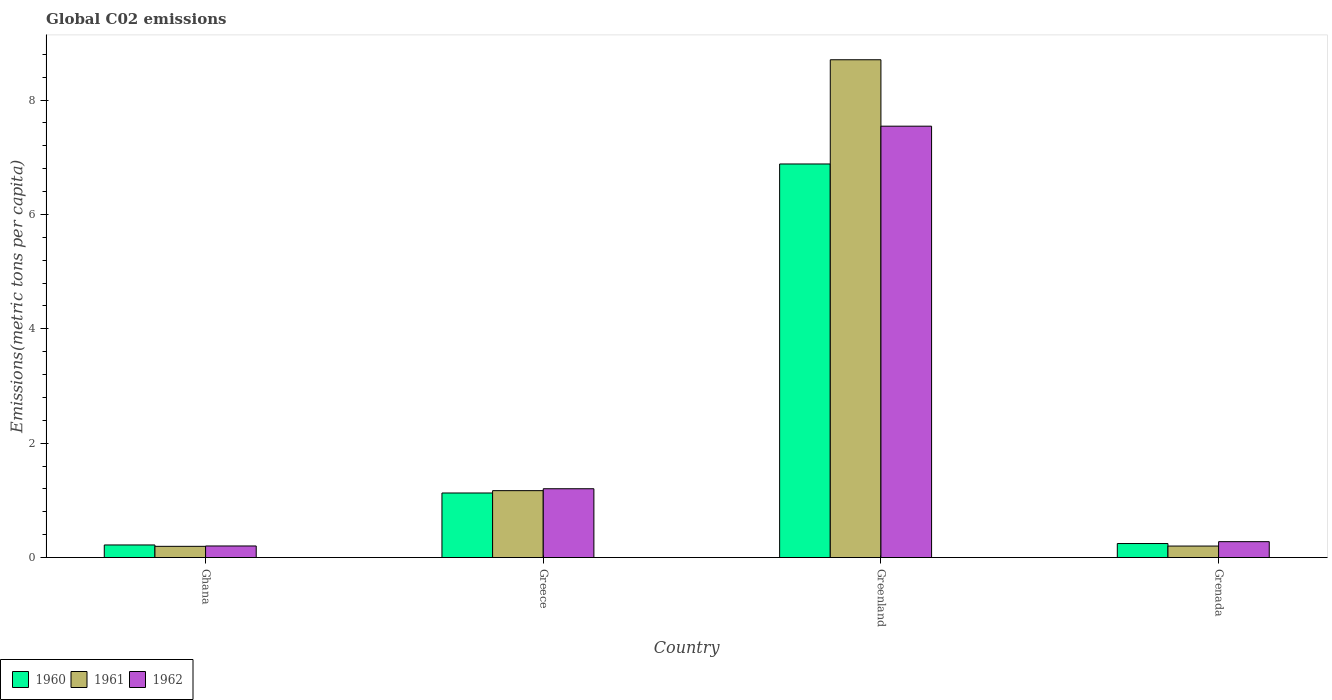How many different coloured bars are there?
Ensure brevity in your answer.  3. How many groups of bars are there?
Provide a short and direct response. 4. Are the number of bars on each tick of the X-axis equal?
Provide a succinct answer. Yes. How many bars are there on the 4th tick from the left?
Offer a terse response. 3. How many bars are there on the 4th tick from the right?
Provide a succinct answer. 3. In how many cases, is the number of bars for a given country not equal to the number of legend labels?
Give a very brief answer. 0. What is the amount of CO2 emitted in in 1960 in Grenada?
Offer a terse response. 0.24. Across all countries, what is the maximum amount of CO2 emitted in in 1960?
Offer a terse response. 6.88. Across all countries, what is the minimum amount of CO2 emitted in in 1960?
Your answer should be very brief. 0.22. In which country was the amount of CO2 emitted in in 1962 maximum?
Your answer should be compact. Greenland. In which country was the amount of CO2 emitted in in 1960 minimum?
Your answer should be very brief. Ghana. What is the total amount of CO2 emitted in in 1962 in the graph?
Make the answer very short. 9.23. What is the difference between the amount of CO2 emitted in in 1960 in Greece and that in Grenada?
Ensure brevity in your answer.  0.88. What is the difference between the amount of CO2 emitted in in 1960 in Greece and the amount of CO2 emitted in in 1962 in Greenland?
Your answer should be very brief. -6.41. What is the average amount of CO2 emitted in in 1960 per country?
Ensure brevity in your answer.  2.12. What is the difference between the amount of CO2 emitted in of/in 1961 and amount of CO2 emitted in of/in 1962 in Greenland?
Ensure brevity in your answer.  1.16. In how many countries, is the amount of CO2 emitted in in 1960 greater than 0.8 metric tons per capita?
Offer a very short reply. 2. What is the ratio of the amount of CO2 emitted in in 1960 in Greece to that in Greenland?
Your answer should be compact. 0.16. Is the amount of CO2 emitted in in 1961 in Greenland less than that in Grenada?
Give a very brief answer. No. Is the difference between the amount of CO2 emitted in in 1961 in Ghana and Grenada greater than the difference between the amount of CO2 emitted in in 1962 in Ghana and Grenada?
Provide a succinct answer. Yes. What is the difference between the highest and the second highest amount of CO2 emitted in in 1961?
Ensure brevity in your answer.  7.54. What is the difference between the highest and the lowest amount of CO2 emitted in in 1961?
Make the answer very short. 8.51. In how many countries, is the amount of CO2 emitted in in 1960 greater than the average amount of CO2 emitted in in 1960 taken over all countries?
Your answer should be compact. 1. Is the sum of the amount of CO2 emitted in in 1960 in Greenland and Grenada greater than the maximum amount of CO2 emitted in in 1961 across all countries?
Your answer should be compact. No. What does the 3rd bar from the right in Greece represents?
Your answer should be very brief. 1960. Is it the case that in every country, the sum of the amount of CO2 emitted in in 1960 and amount of CO2 emitted in in 1961 is greater than the amount of CO2 emitted in in 1962?
Ensure brevity in your answer.  Yes. Are all the bars in the graph horizontal?
Your response must be concise. No. How many countries are there in the graph?
Make the answer very short. 4. What is the difference between two consecutive major ticks on the Y-axis?
Ensure brevity in your answer.  2. Are the values on the major ticks of Y-axis written in scientific E-notation?
Offer a terse response. No. Does the graph contain grids?
Your answer should be compact. No. Where does the legend appear in the graph?
Provide a succinct answer. Bottom left. How many legend labels are there?
Make the answer very short. 3. What is the title of the graph?
Ensure brevity in your answer.  Global C02 emissions. What is the label or title of the X-axis?
Offer a very short reply. Country. What is the label or title of the Y-axis?
Ensure brevity in your answer.  Emissions(metric tons per capita). What is the Emissions(metric tons per capita) in 1960 in Ghana?
Ensure brevity in your answer.  0.22. What is the Emissions(metric tons per capita) in 1961 in Ghana?
Offer a terse response. 0.2. What is the Emissions(metric tons per capita) of 1962 in Ghana?
Provide a short and direct response. 0.2. What is the Emissions(metric tons per capita) of 1960 in Greece?
Your response must be concise. 1.13. What is the Emissions(metric tons per capita) of 1961 in Greece?
Your response must be concise. 1.17. What is the Emissions(metric tons per capita) in 1962 in Greece?
Ensure brevity in your answer.  1.2. What is the Emissions(metric tons per capita) of 1960 in Greenland?
Offer a terse response. 6.88. What is the Emissions(metric tons per capita) of 1961 in Greenland?
Offer a very short reply. 8.71. What is the Emissions(metric tons per capita) of 1962 in Greenland?
Your answer should be very brief. 7.54. What is the Emissions(metric tons per capita) of 1960 in Grenada?
Provide a short and direct response. 0.24. What is the Emissions(metric tons per capita) in 1961 in Grenada?
Provide a succinct answer. 0.2. What is the Emissions(metric tons per capita) in 1962 in Grenada?
Your answer should be very brief. 0.28. Across all countries, what is the maximum Emissions(metric tons per capita) of 1960?
Keep it short and to the point. 6.88. Across all countries, what is the maximum Emissions(metric tons per capita) of 1961?
Your answer should be compact. 8.71. Across all countries, what is the maximum Emissions(metric tons per capita) in 1962?
Keep it short and to the point. 7.54. Across all countries, what is the minimum Emissions(metric tons per capita) of 1960?
Offer a terse response. 0.22. Across all countries, what is the minimum Emissions(metric tons per capita) of 1961?
Your response must be concise. 0.2. Across all countries, what is the minimum Emissions(metric tons per capita) of 1962?
Keep it short and to the point. 0.2. What is the total Emissions(metric tons per capita) in 1960 in the graph?
Provide a succinct answer. 8.48. What is the total Emissions(metric tons per capita) of 1961 in the graph?
Give a very brief answer. 10.27. What is the total Emissions(metric tons per capita) of 1962 in the graph?
Keep it short and to the point. 9.23. What is the difference between the Emissions(metric tons per capita) in 1960 in Ghana and that in Greece?
Provide a short and direct response. -0.91. What is the difference between the Emissions(metric tons per capita) in 1961 in Ghana and that in Greece?
Provide a short and direct response. -0.97. What is the difference between the Emissions(metric tons per capita) of 1962 in Ghana and that in Greece?
Keep it short and to the point. -1. What is the difference between the Emissions(metric tons per capita) in 1960 in Ghana and that in Greenland?
Your response must be concise. -6.66. What is the difference between the Emissions(metric tons per capita) of 1961 in Ghana and that in Greenland?
Your response must be concise. -8.51. What is the difference between the Emissions(metric tons per capita) in 1962 in Ghana and that in Greenland?
Make the answer very short. -7.34. What is the difference between the Emissions(metric tons per capita) of 1960 in Ghana and that in Grenada?
Keep it short and to the point. -0.02. What is the difference between the Emissions(metric tons per capita) of 1961 in Ghana and that in Grenada?
Make the answer very short. -0. What is the difference between the Emissions(metric tons per capita) of 1962 in Ghana and that in Grenada?
Keep it short and to the point. -0.08. What is the difference between the Emissions(metric tons per capita) in 1960 in Greece and that in Greenland?
Keep it short and to the point. -5.75. What is the difference between the Emissions(metric tons per capita) of 1961 in Greece and that in Greenland?
Make the answer very short. -7.54. What is the difference between the Emissions(metric tons per capita) of 1962 in Greece and that in Greenland?
Your response must be concise. -6.34. What is the difference between the Emissions(metric tons per capita) of 1960 in Greece and that in Grenada?
Give a very brief answer. 0.88. What is the difference between the Emissions(metric tons per capita) of 1961 in Greece and that in Grenada?
Give a very brief answer. 0.97. What is the difference between the Emissions(metric tons per capita) in 1962 in Greece and that in Grenada?
Keep it short and to the point. 0.93. What is the difference between the Emissions(metric tons per capita) in 1960 in Greenland and that in Grenada?
Provide a succinct answer. 6.64. What is the difference between the Emissions(metric tons per capita) in 1961 in Greenland and that in Grenada?
Your answer should be very brief. 8.5. What is the difference between the Emissions(metric tons per capita) in 1962 in Greenland and that in Grenada?
Provide a succinct answer. 7.27. What is the difference between the Emissions(metric tons per capita) in 1960 in Ghana and the Emissions(metric tons per capita) in 1961 in Greece?
Offer a terse response. -0.95. What is the difference between the Emissions(metric tons per capita) of 1960 in Ghana and the Emissions(metric tons per capita) of 1962 in Greece?
Your answer should be compact. -0.98. What is the difference between the Emissions(metric tons per capita) in 1961 in Ghana and the Emissions(metric tons per capita) in 1962 in Greece?
Provide a succinct answer. -1.01. What is the difference between the Emissions(metric tons per capita) of 1960 in Ghana and the Emissions(metric tons per capita) of 1961 in Greenland?
Offer a very short reply. -8.49. What is the difference between the Emissions(metric tons per capita) of 1960 in Ghana and the Emissions(metric tons per capita) of 1962 in Greenland?
Offer a terse response. -7.32. What is the difference between the Emissions(metric tons per capita) in 1961 in Ghana and the Emissions(metric tons per capita) in 1962 in Greenland?
Offer a terse response. -7.35. What is the difference between the Emissions(metric tons per capita) of 1960 in Ghana and the Emissions(metric tons per capita) of 1961 in Grenada?
Give a very brief answer. 0.02. What is the difference between the Emissions(metric tons per capita) of 1960 in Ghana and the Emissions(metric tons per capita) of 1962 in Grenada?
Your answer should be very brief. -0.06. What is the difference between the Emissions(metric tons per capita) in 1961 in Ghana and the Emissions(metric tons per capita) in 1962 in Grenada?
Offer a terse response. -0.08. What is the difference between the Emissions(metric tons per capita) of 1960 in Greece and the Emissions(metric tons per capita) of 1961 in Greenland?
Offer a very short reply. -7.58. What is the difference between the Emissions(metric tons per capita) in 1960 in Greece and the Emissions(metric tons per capita) in 1962 in Greenland?
Make the answer very short. -6.41. What is the difference between the Emissions(metric tons per capita) of 1961 in Greece and the Emissions(metric tons per capita) of 1962 in Greenland?
Offer a terse response. -6.37. What is the difference between the Emissions(metric tons per capita) of 1960 in Greece and the Emissions(metric tons per capita) of 1961 in Grenada?
Provide a short and direct response. 0.93. What is the difference between the Emissions(metric tons per capita) of 1960 in Greece and the Emissions(metric tons per capita) of 1962 in Grenada?
Give a very brief answer. 0.85. What is the difference between the Emissions(metric tons per capita) of 1961 in Greece and the Emissions(metric tons per capita) of 1962 in Grenada?
Provide a succinct answer. 0.89. What is the difference between the Emissions(metric tons per capita) of 1960 in Greenland and the Emissions(metric tons per capita) of 1961 in Grenada?
Ensure brevity in your answer.  6.68. What is the difference between the Emissions(metric tons per capita) of 1960 in Greenland and the Emissions(metric tons per capita) of 1962 in Grenada?
Provide a short and direct response. 6.6. What is the difference between the Emissions(metric tons per capita) of 1961 in Greenland and the Emissions(metric tons per capita) of 1962 in Grenada?
Your answer should be very brief. 8.43. What is the average Emissions(metric tons per capita) in 1960 per country?
Give a very brief answer. 2.12. What is the average Emissions(metric tons per capita) in 1961 per country?
Ensure brevity in your answer.  2.57. What is the average Emissions(metric tons per capita) of 1962 per country?
Provide a succinct answer. 2.31. What is the difference between the Emissions(metric tons per capita) in 1960 and Emissions(metric tons per capita) in 1961 in Ghana?
Offer a very short reply. 0.02. What is the difference between the Emissions(metric tons per capita) in 1960 and Emissions(metric tons per capita) in 1962 in Ghana?
Give a very brief answer. 0.02. What is the difference between the Emissions(metric tons per capita) in 1961 and Emissions(metric tons per capita) in 1962 in Ghana?
Offer a terse response. -0.01. What is the difference between the Emissions(metric tons per capita) in 1960 and Emissions(metric tons per capita) in 1961 in Greece?
Offer a very short reply. -0.04. What is the difference between the Emissions(metric tons per capita) of 1960 and Emissions(metric tons per capita) of 1962 in Greece?
Provide a succinct answer. -0.07. What is the difference between the Emissions(metric tons per capita) in 1961 and Emissions(metric tons per capita) in 1962 in Greece?
Offer a terse response. -0.03. What is the difference between the Emissions(metric tons per capita) of 1960 and Emissions(metric tons per capita) of 1961 in Greenland?
Provide a succinct answer. -1.82. What is the difference between the Emissions(metric tons per capita) in 1960 and Emissions(metric tons per capita) in 1962 in Greenland?
Give a very brief answer. -0.66. What is the difference between the Emissions(metric tons per capita) in 1961 and Emissions(metric tons per capita) in 1962 in Greenland?
Provide a short and direct response. 1.16. What is the difference between the Emissions(metric tons per capita) of 1960 and Emissions(metric tons per capita) of 1961 in Grenada?
Provide a short and direct response. 0.04. What is the difference between the Emissions(metric tons per capita) in 1960 and Emissions(metric tons per capita) in 1962 in Grenada?
Offer a very short reply. -0.03. What is the difference between the Emissions(metric tons per capita) of 1961 and Emissions(metric tons per capita) of 1962 in Grenada?
Make the answer very short. -0.08. What is the ratio of the Emissions(metric tons per capita) in 1960 in Ghana to that in Greece?
Your answer should be compact. 0.19. What is the ratio of the Emissions(metric tons per capita) in 1961 in Ghana to that in Greece?
Make the answer very short. 0.17. What is the ratio of the Emissions(metric tons per capita) in 1962 in Ghana to that in Greece?
Provide a succinct answer. 0.17. What is the ratio of the Emissions(metric tons per capita) in 1960 in Ghana to that in Greenland?
Give a very brief answer. 0.03. What is the ratio of the Emissions(metric tons per capita) in 1961 in Ghana to that in Greenland?
Provide a short and direct response. 0.02. What is the ratio of the Emissions(metric tons per capita) in 1962 in Ghana to that in Greenland?
Your answer should be compact. 0.03. What is the ratio of the Emissions(metric tons per capita) in 1960 in Ghana to that in Grenada?
Keep it short and to the point. 0.9. What is the ratio of the Emissions(metric tons per capita) in 1961 in Ghana to that in Grenada?
Make the answer very short. 0.98. What is the ratio of the Emissions(metric tons per capita) of 1962 in Ghana to that in Grenada?
Your answer should be very brief. 0.73. What is the ratio of the Emissions(metric tons per capita) of 1960 in Greece to that in Greenland?
Offer a terse response. 0.16. What is the ratio of the Emissions(metric tons per capita) in 1961 in Greece to that in Greenland?
Ensure brevity in your answer.  0.13. What is the ratio of the Emissions(metric tons per capita) of 1962 in Greece to that in Greenland?
Your answer should be compact. 0.16. What is the ratio of the Emissions(metric tons per capita) in 1960 in Greece to that in Grenada?
Make the answer very short. 4.61. What is the ratio of the Emissions(metric tons per capita) of 1961 in Greece to that in Grenada?
Make the answer very short. 5.82. What is the ratio of the Emissions(metric tons per capita) in 1962 in Greece to that in Grenada?
Offer a terse response. 4.33. What is the ratio of the Emissions(metric tons per capita) in 1960 in Greenland to that in Grenada?
Keep it short and to the point. 28.11. What is the ratio of the Emissions(metric tons per capita) of 1961 in Greenland to that in Grenada?
Give a very brief answer. 43.33. What is the ratio of the Emissions(metric tons per capita) of 1962 in Greenland to that in Grenada?
Your response must be concise. 27.16. What is the difference between the highest and the second highest Emissions(metric tons per capita) of 1960?
Ensure brevity in your answer.  5.75. What is the difference between the highest and the second highest Emissions(metric tons per capita) in 1961?
Make the answer very short. 7.54. What is the difference between the highest and the second highest Emissions(metric tons per capita) of 1962?
Ensure brevity in your answer.  6.34. What is the difference between the highest and the lowest Emissions(metric tons per capita) of 1960?
Provide a succinct answer. 6.66. What is the difference between the highest and the lowest Emissions(metric tons per capita) of 1961?
Offer a terse response. 8.51. What is the difference between the highest and the lowest Emissions(metric tons per capita) in 1962?
Ensure brevity in your answer.  7.34. 